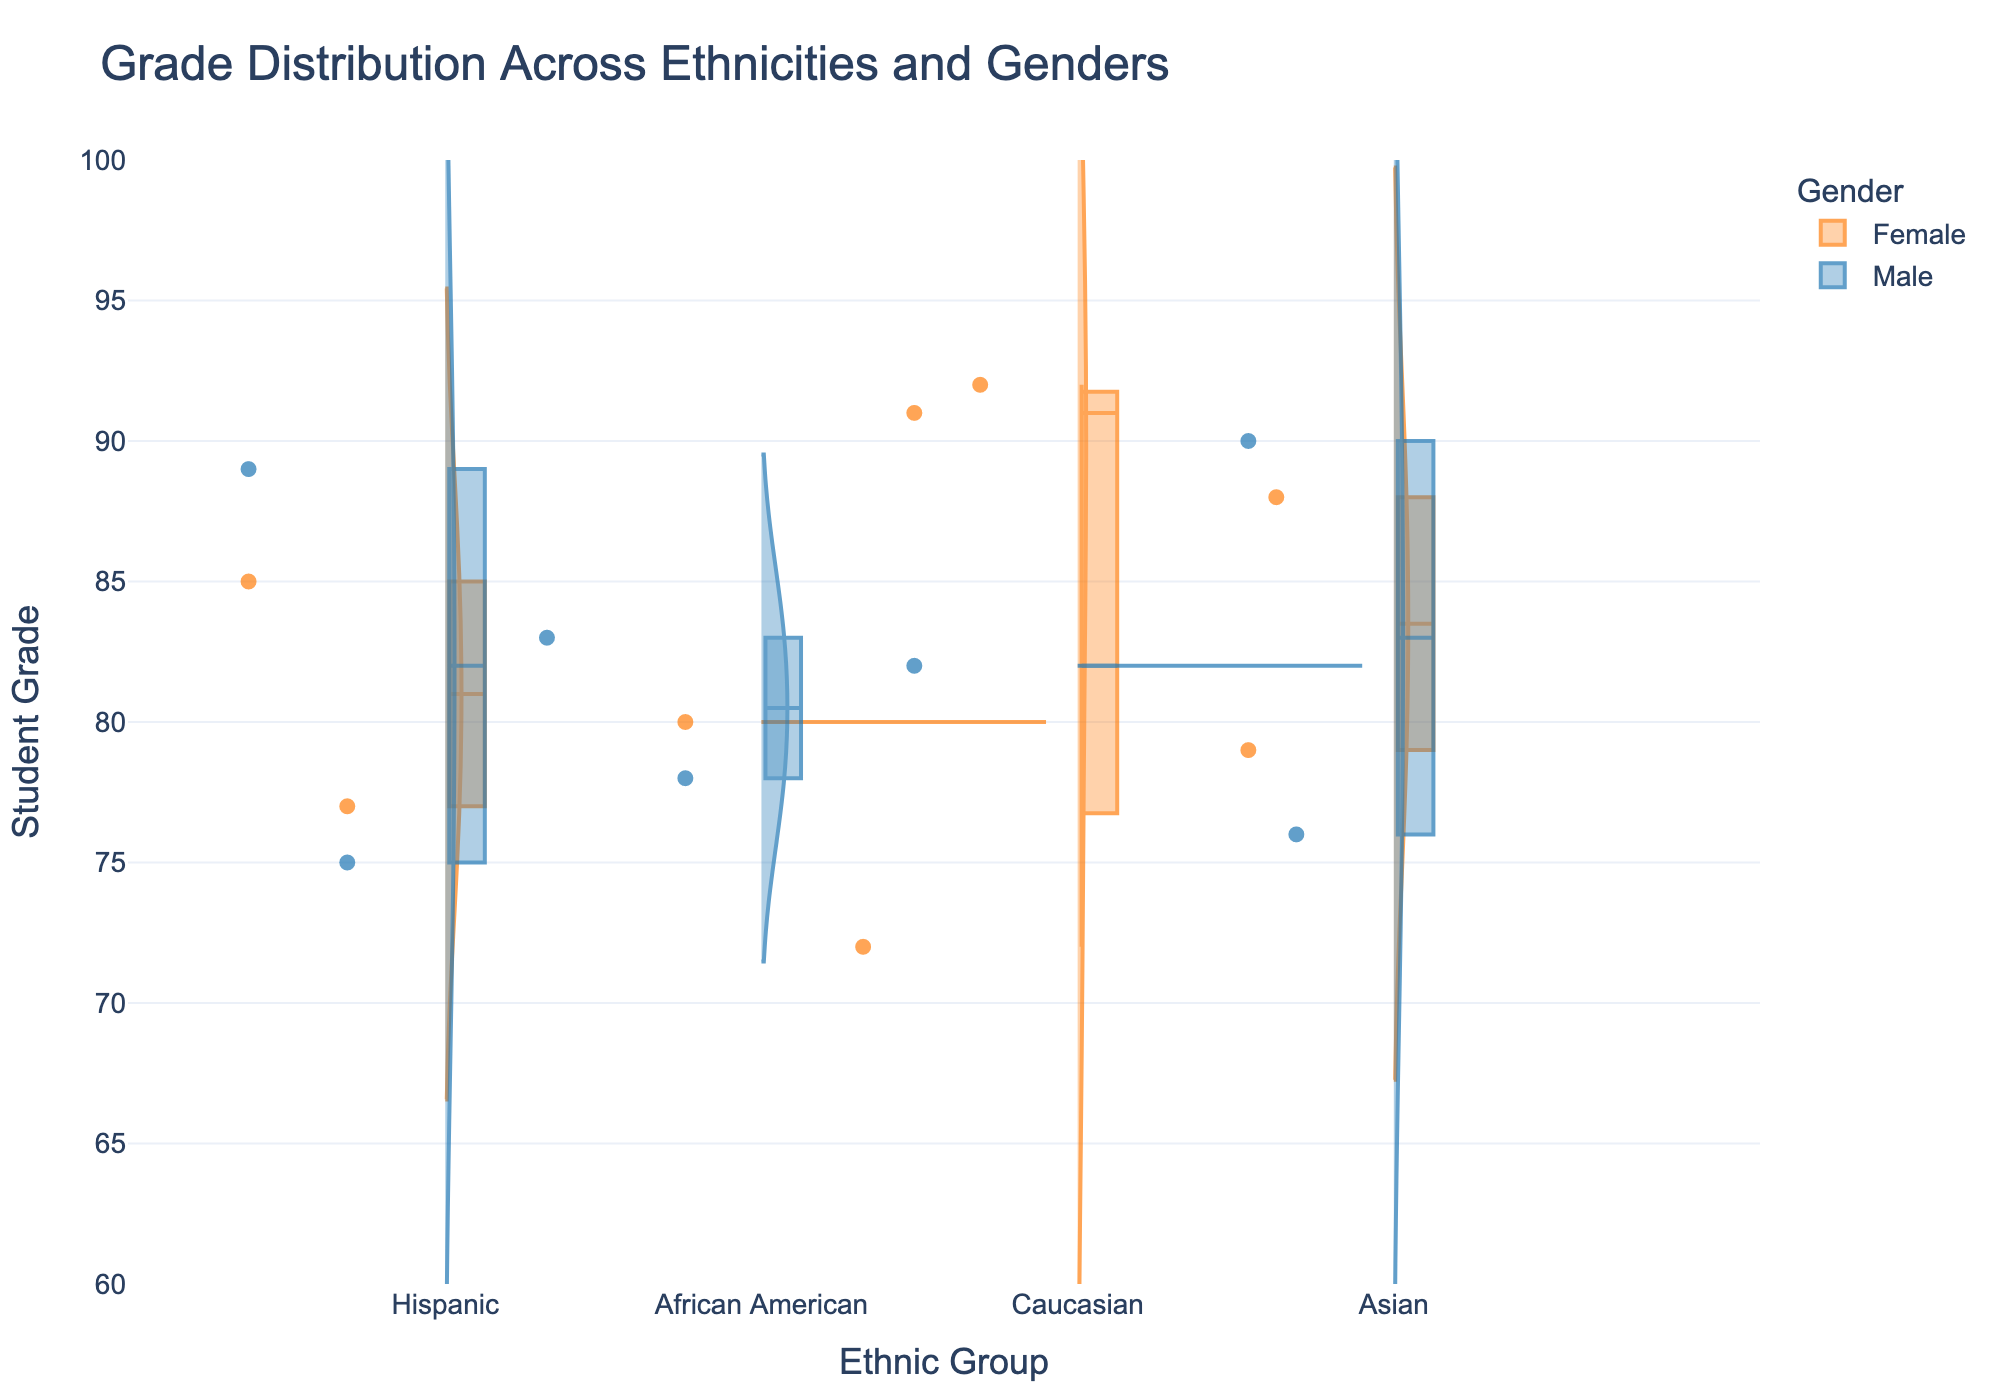What is the title of the chart? The title is displayed at the top of the chart, summarizing what the figure represents.
Answer: Grade Distribution Across Ethnicities and Genders Which gender is represented by the blue color in the chart? The legend at the top right of the chart maps colors to genders. The blue color corresponds to Male.
Answer: Male What is the range of grades displayed on the y-axis? The y-axis range is shown on the left side of the chart, indicating that it spans from 60 to 100.
Answer: 60 to 100 How many ethnic groups are represented in the x-axis? The x-axis displays categories representing different ethnic groups. The chart shows four categories: Hispanic, African American, Caucasian, and Asian.
Answer: 4 Which gender has a higher median grade among Caucasian students? By referencing the box plot within the violin for Caucasian students, it is evident that the median for females is higher than that for males.
Answer: Female Among the 18-22 age group, which ethnic group has the highest grade? Look at the individual data points within each violin plot for the 18-22 age group and identify the highest grade. The highest grade of 92 is seen in the Caucasian group.
Answer: Caucasian What is the median grade for Hispanic males? The median grade for Hispanic males is represented by the middle line in the box plot within the violin plot. It can be seen that the median grade is around 85.
Answer: Around 85 Which ethnic group shows the widest spread of grades for females? By observing the spread of grades on the y-axis within each violin plot for females, the Asian group shows the broadest range from top to bottom.
Answer: Asian Compare the grade distribution of African American males vs. Hispanic males. Which group has higher grade variation? The variation in grades is indicated by the spread of the violin plot. African American males show a narrower spread, indicating less variation compared to Hispanic males.
Answer: Hispanic males Which location has students represented in all four ethnic groups? By examining the hover data or labels for each data point, it is evident that California has students in all four ethnic groups.
Answer: California 